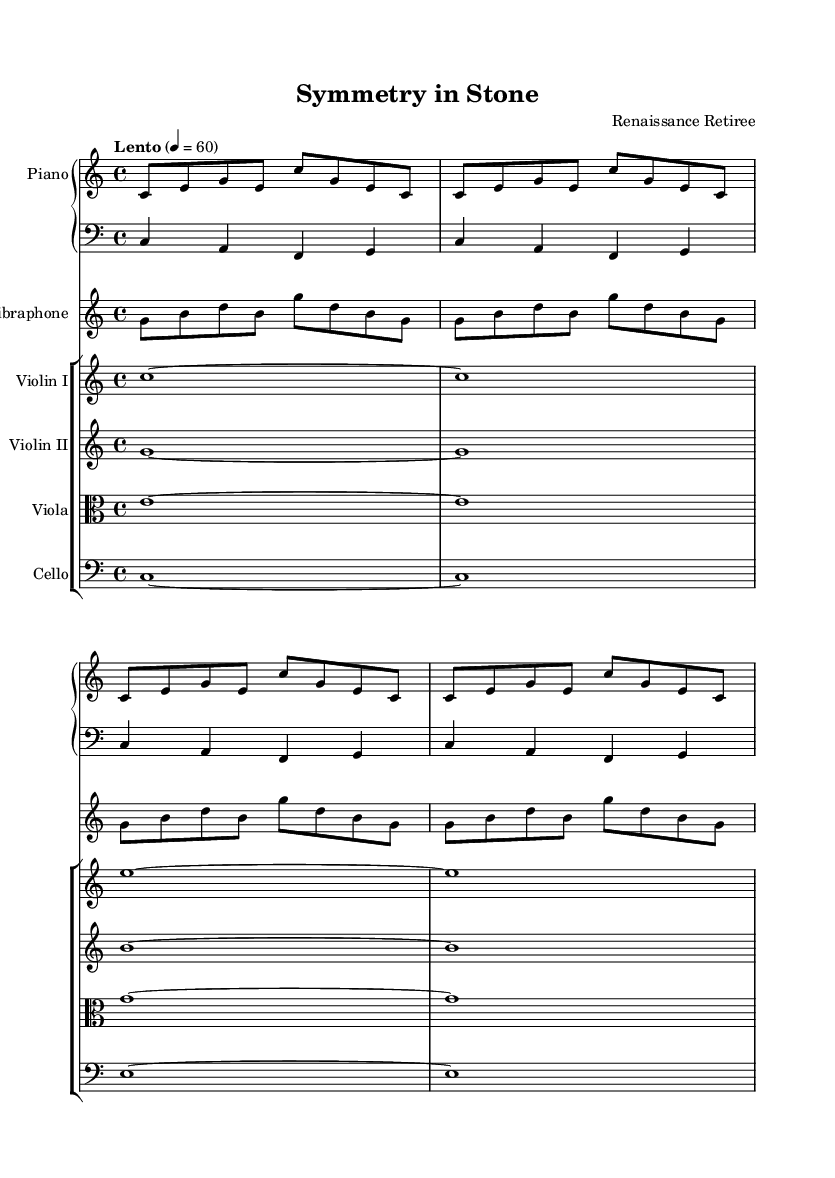What is the key signature of this music? The key signature is C major, indicated by the absence of any sharps or flats on the staff.
Answer: C major What is the time signature of this composition? The time signature is 4/4, as noted at the beginning of the score, meaning there are four beats per measure.
Answer: 4/4 What is the tempo marking for this piece? The tempo is marked as "Lento," which indicates a slow pace. Additionally, the metronome marking of 60 means there are 60 beats per minute.
Answer: Lento How many measures are present in the piano right hand? In the piano right hand part, there are 4 repeated measures, as shown by the "repeat unfold" directive that indicates the same section is played multiple times.
Answer: 4 What instruments are included in this composition? The score lists several instruments: Piano, Vibraphone, Violin I, Violin II, Viola, and Cello, each with its own dedicated staff.
Answer: Piano, Vibraphone, Violin I, Violin II, Viola, Cello What type of composition does this represent? This music can be classified as Experimental, given its minimalist approach and inspiration from Renaissance architecture, focusing on geometric patterns in the music.
Answer: Experimental How is the structure of this piece reflected in the arrangement of instruments? The arrangement has a mix of textures, with the piano providing harmony, while strings contribute melodic lines, reflecting a layered approach typical of minimalist compositions.
Answer: Layered approach 